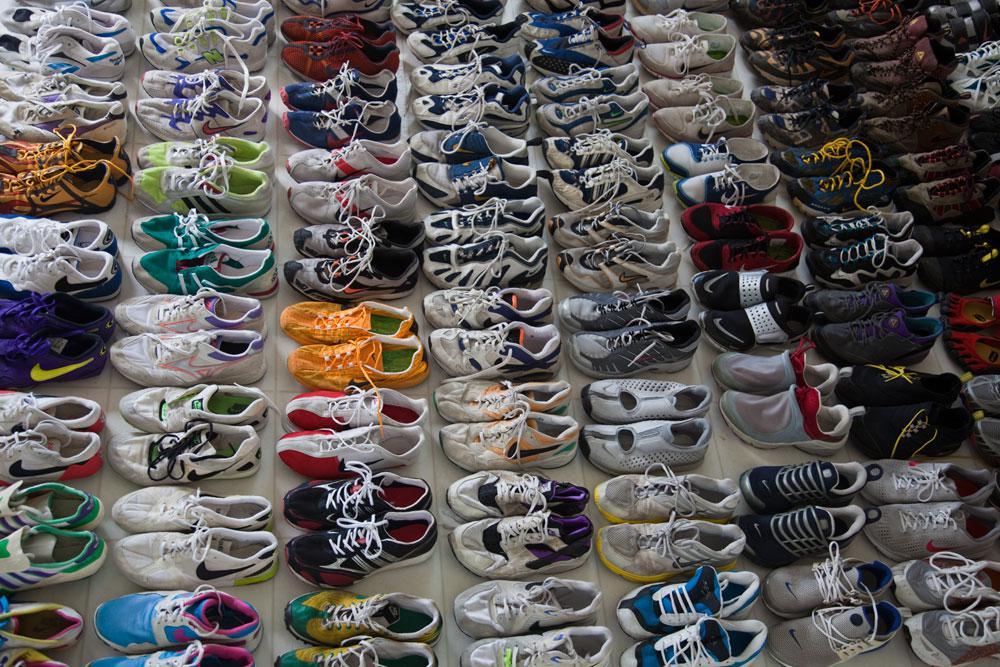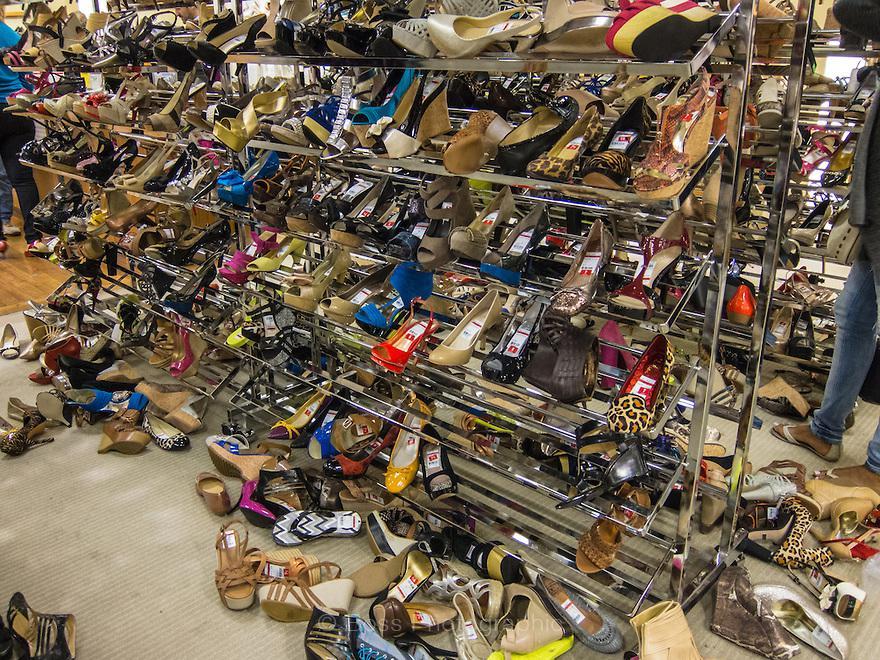The first image is the image on the left, the second image is the image on the right. For the images shown, is this caption "The shoes are displayed horizontally on the wall in the image on the right." true? Answer yes or no. No. 